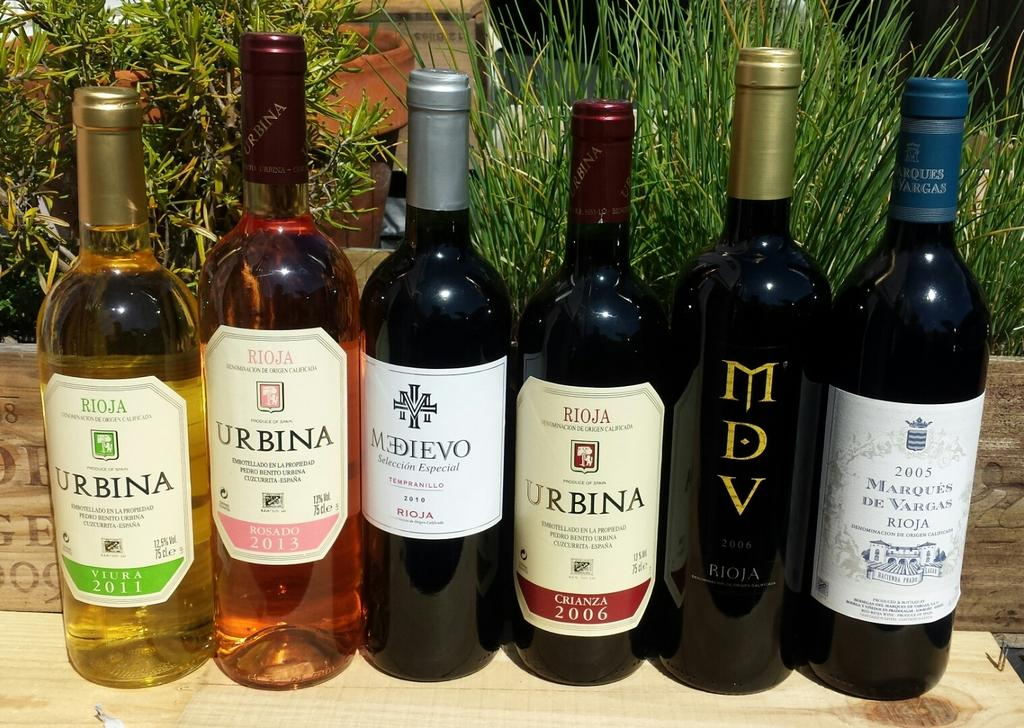Provide a one-sentence caption for the provided image. Half on the wines that shown have the name Urbina. 